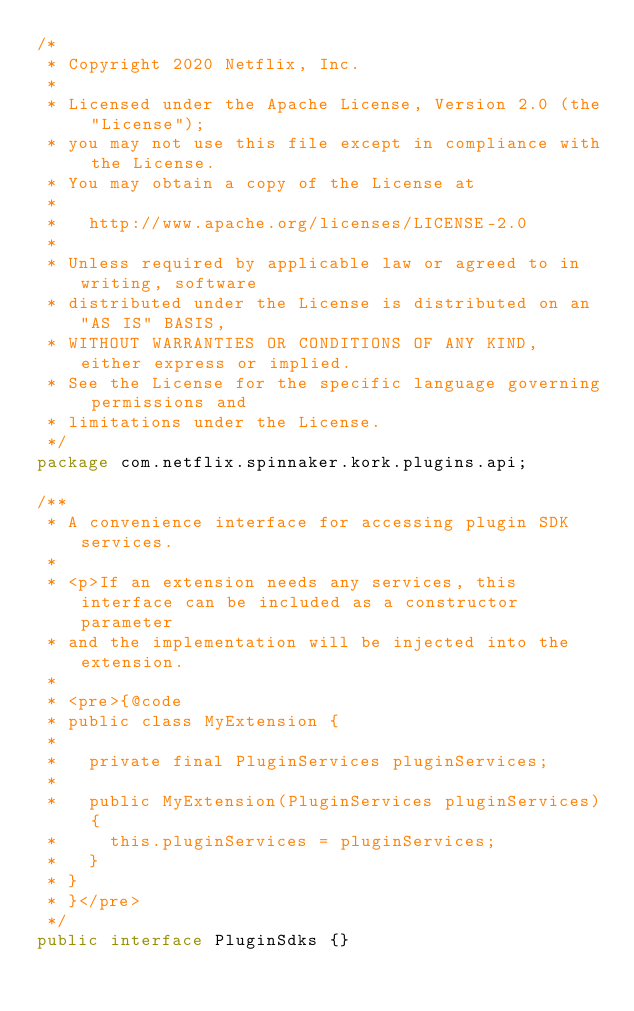Convert code to text. <code><loc_0><loc_0><loc_500><loc_500><_Java_>/*
 * Copyright 2020 Netflix, Inc.
 *
 * Licensed under the Apache License, Version 2.0 (the "License");
 * you may not use this file except in compliance with the License.
 * You may obtain a copy of the License at
 *
 *   http://www.apache.org/licenses/LICENSE-2.0
 *
 * Unless required by applicable law or agreed to in writing, software
 * distributed under the License is distributed on an "AS IS" BASIS,
 * WITHOUT WARRANTIES OR CONDITIONS OF ANY KIND, either express or implied.
 * See the License for the specific language governing permissions and
 * limitations under the License.
 */
package com.netflix.spinnaker.kork.plugins.api;

/**
 * A convenience interface for accessing plugin SDK services.
 *
 * <p>If an extension needs any services, this interface can be included as a constructor parameter
 * and the implementation will be injected into the extension.
 *
 * <pre>{@code
 * public class MyExtension {
 *
 *   private final PluginServices pluginServices;
 *
 *   public MyExtension(PluginServices pluginServices) {
 *     this.pluginServices = pluginServices;
 *   }
 * }
 * }</pre>
 */
public interface PluginSdks {}
</code> 